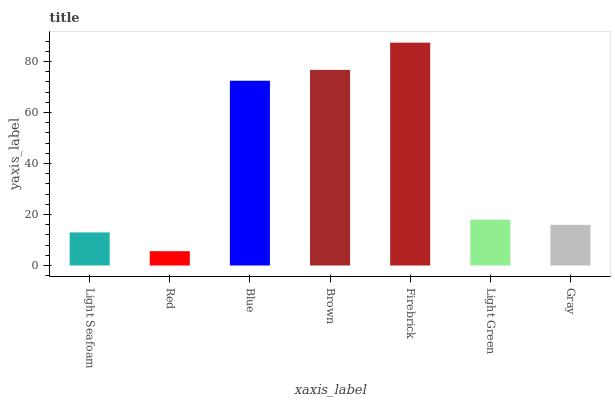Is Red the minimum?
Answer yes or no. Yes. Is Firebrick the maximum?
Answer yes or no. Yes. Is Blue the minimum?
Answer yes or no. No. Is Blue the maximum?
Answer yes or no. No. Is Blue greater than Red?
Answer yes or no. Yes. Is Red less than Blue?
Answer yes or no. Yes. Is Red greater than Blue?
Answer yes or no. No. Is Blue less than Red?
Answer yes or no. No. Is Light Green the high median?
Answer yes or no. Yes. Is Light Green the low median?
Answer yes or no. Yes. Is Firebrick the high median?
Answer yes or no. No. Is Blue the low median?
Answer yes or no. No. 